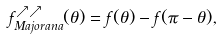<formula> <loc_0><loc_0><loc_500><loc_500>f _ { M a j o r a n a } ^ { \nearrow \nearrow } ( \theta ) = f ( \theta ) - f ( \pi - \theta ) ,</formula> 